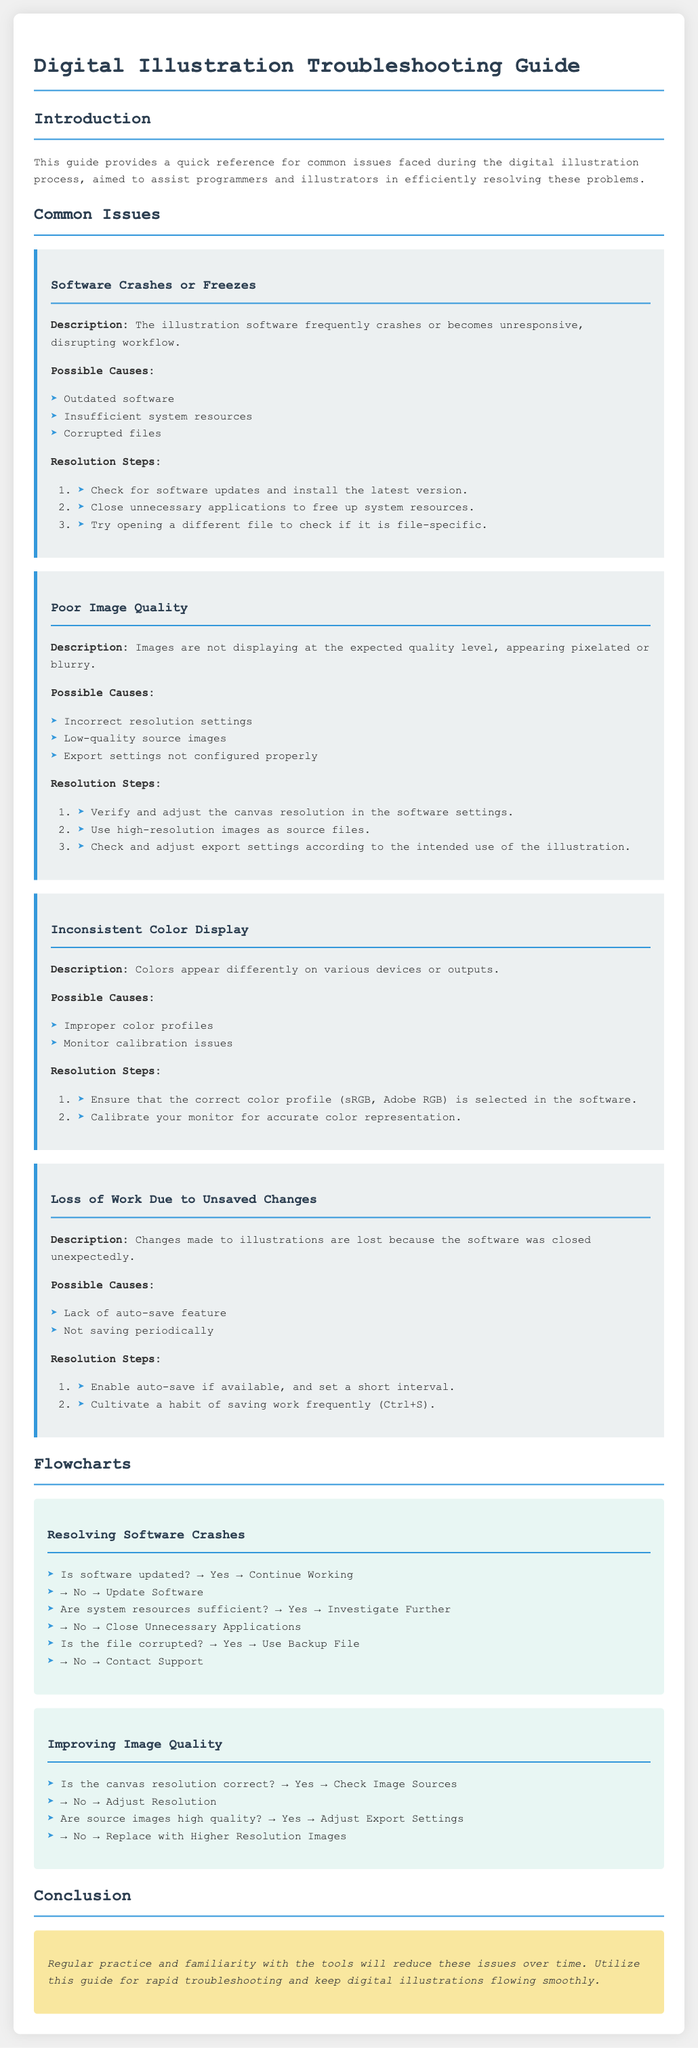What is the title of the document? The title of the document is specified in the <title> tag, which is a summary of its content.
Answer: Digital Illustration Troubleshooting Guide What is one possible cause of software crashes? The document lists several possible causes of software crashes within the relevant issue section.
Answer: Outdated software What should you do to improve image quality? The document outlines resolution steps that need to be taken in order to improve image quality.
Answer: Verify and adjust the canvas resolution What feature should be enabled to prevent loss of work? The resolution steps for loss of work include a suggestion to activate a specific feature for safety during illustration work.
Answer: Auto-save Who should you contact if the file is not corrupted and you still face software crashes? The document provides specific instructions on who to contact in case certain preliminary checks are satisfied but issues persist.
Answer: Contact Support What is one cause of inconsistent color display? The section on inconsistent color display presents possible causes, one of which can be identified easily.
Answer: Improper color profiles What does the flowchart for resolving software crashes start with? The flowchart outlines a process that begins with an initial check related to software status.
Answer: Is software updated? How can you check if the source images are of high quality? The document specifies steps related to source images in the context of improving image quality.
Answer: Adjust Export Settings What is the background color of the flowchart section? The document includes visual elements that designates the appearance of various sections, including this one.
Answer: Light aqua (e8f6f3) 